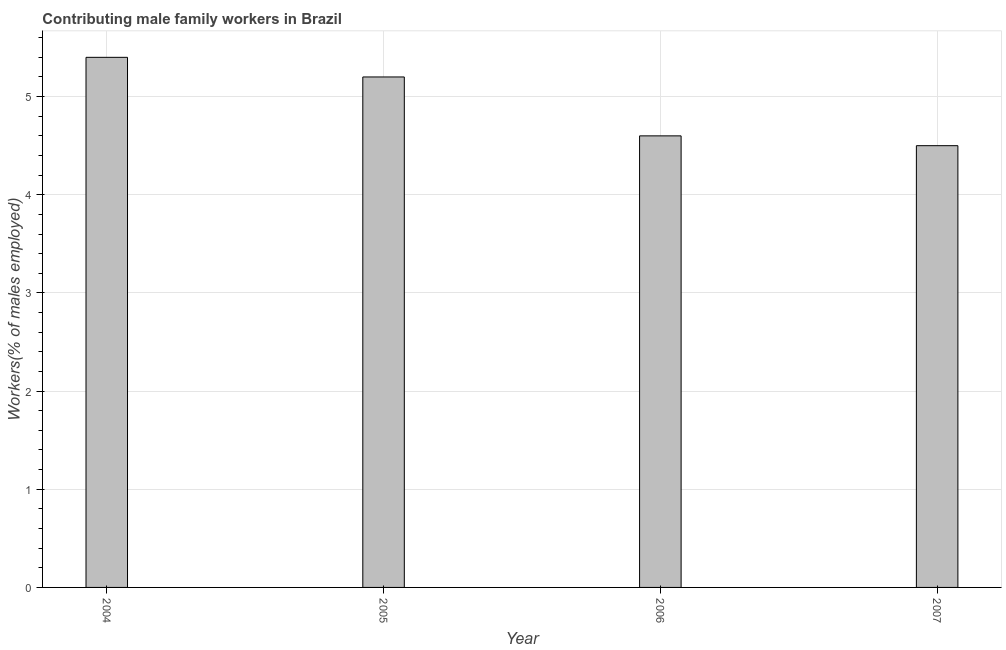Does the graph contain any zero values?
Ensure brevity in your answer.  No. Does the graph contain grids?
Give a very brief answer. Yes. What is the title of the graph?
Offer a terse response. Contributing male family workers in Brazil. What is the label or title of the X-axis?
Ensure brevity in your answer.  Year. What is the label or title of the Y-axis?
Provide a short and direct response. Workers(% of males employed). Across all years, what is the maximum contributing male family workers?
Ensure brevity in your answer.  5.4. Across all years, what is the minimum contributing male family workers?
Provide a short and direct response. 4.5. In which year was the contributing male family workers maximum?
Provide a succinct answer. 2004. In which year was the contributing male family workers minimum?
Your response must be concise. 2007. What is the sum of the contributing male family workers?
Give a very brief answer. 19.7. What is the average contributing male family workers per year?
Your answer should be very brief. 4.92. What is the median contributing male family workers?
Offer a terse response. 4.9. Do a majority of the years between 2006 and 2005 (inclusive) have contributing male family workers greater than 0.6 %?
Ensure brevity in your answer.  No. What is the ratio of the contributing male family workers in 2005 to that in 2006?
Your answer should be very brief. 1.13. Is the difference between the contributing male family workers in 2006 and 2007 greater than the difference between any two years?
Ensure brevity in your answer.  No. What is the difference between the highest and the second highest contributing male family workers?
Keep it short and to the point. 0.2. Are all the bars in the graph horizontal?
Offer a very short reply. No. What is the difference between two consecutive major ticks on the Y-axis?
Your answer should be very brief. 1. What is the Workers(% of males employed) in 2004?
Keep it short and to the point. 5.4. What is the Workers(% of males employed) in 2005?
Ensure brevity in your answer.  5.2. What is the Workers(% of males employed) in 2006?
Give a very brief answer. 4.6. What is the difference between the Workers(% of males employed) in 2004 and 2005?
Make the answer very short. 0.2. What is the difference between the Workers(% of males employed) in 2005 and 2007?
Ensure brevity in your answer.  0.7. What is the difference between the Workers(% of males employed) in 2006 and 2007?
Your response must be concise. 0.1. What is the ratio of the Workers(% of males employed) in 2004 to that in 2005?
Provide a short and direct response. 1.04. What is the ratio of the Workers(% of males employed) in 2004 to that in 2006?
Ensure brevity in your answer.  1.17. What is the ratio of the Workers(% of males employed) in 2004 to that in 2007?
Your answer should be very brief. 1.2. What is the ratio of the Workers(% of males employed) in 2005 to that in 2006?
Your answer should be compact. 1.13. What is the ratio of the Workers(% of males employed) in 2005 to that in 2007?
Ensure brevity in your answer.  1.16. 